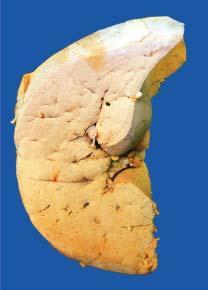what does sectioned slice of the liver show?
Answer the question using a single word or phrase. Pale yellow parenchyma with rounded borders 